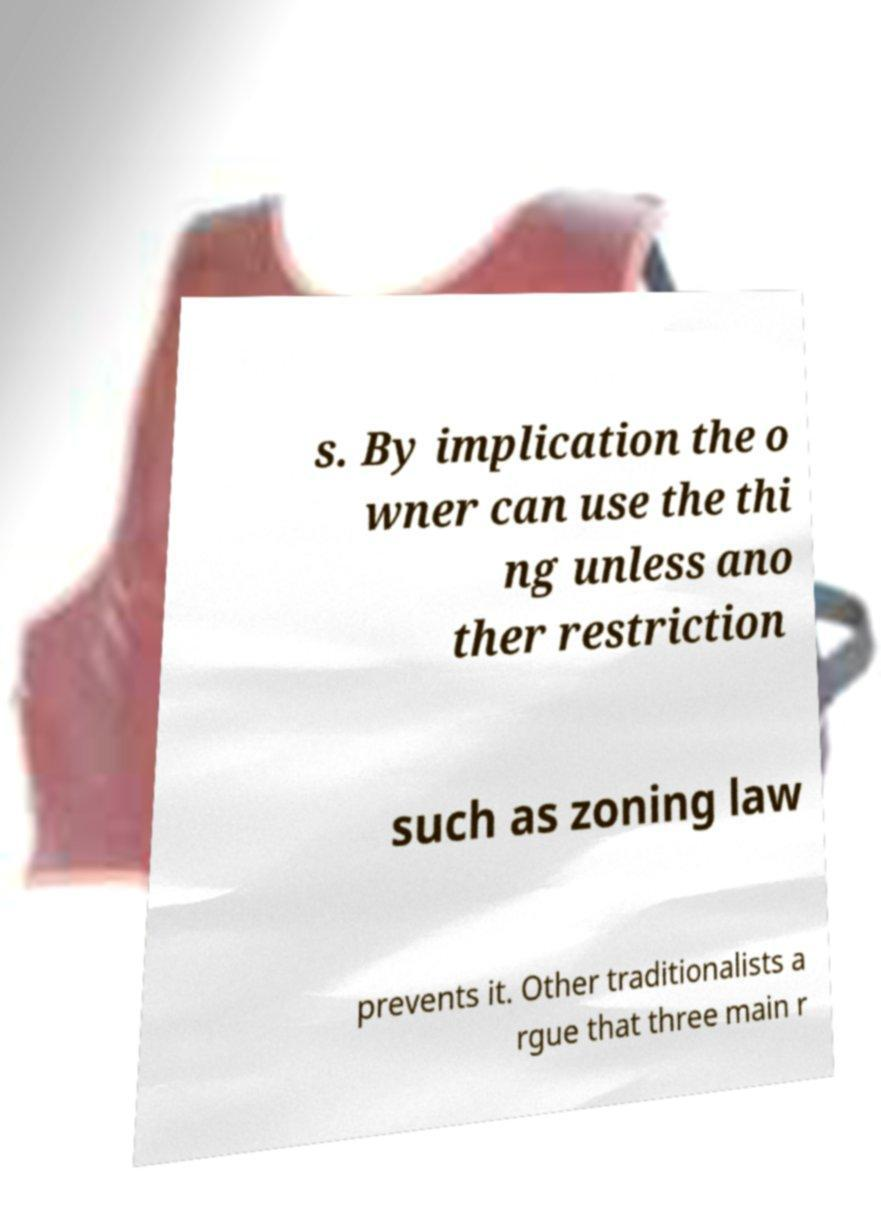What messages or text are displayed in this image? I need them in a readable, typed format. s. By implication the o wner can use the thi ng unless ano ther restriction such as zoning law prevents it. Other traditionalists a rgue that three main r 